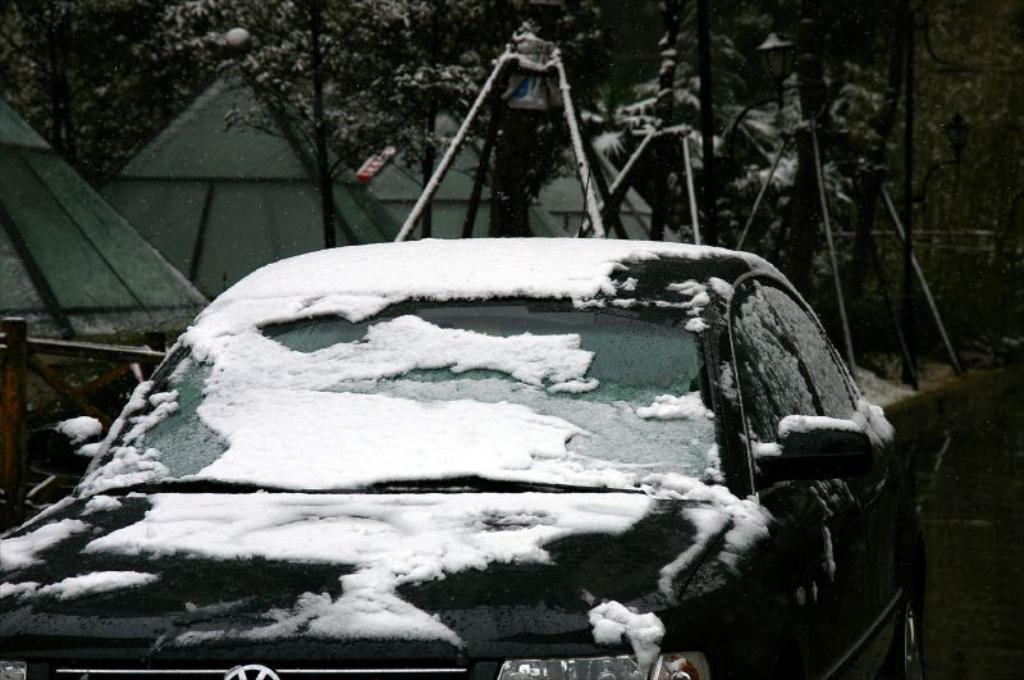Could you give a brief overview of what you see in this image? In the center of the image we can see a car covered by snow. In the background there are seeds and trees. At the bottom there is a road. 